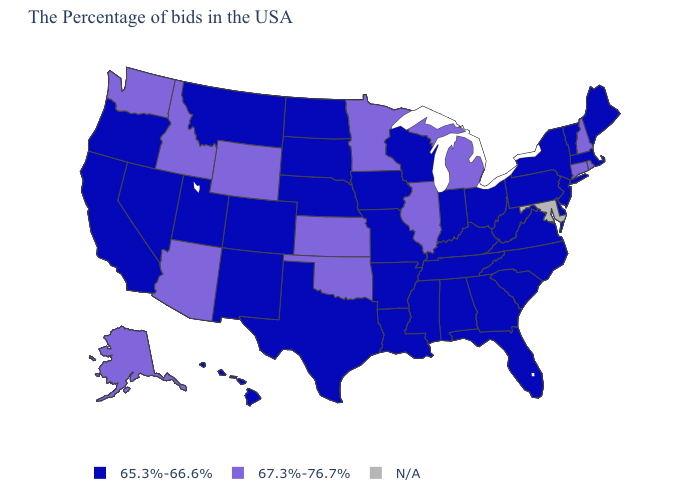Name the states that have a value in the range N/A?
Be succinct. Maryland. What is the value of Vermont?
Give a very brief answer. 65.3%-66.6%. Which states hav the highest value in the West?
Be succinct. Wyoming, Arizona, Idaho, Washington, Alaska. Does the map have missing data?
Give a very brief answer. Yes. Does the first symbol in the legend represent the smallest category?
Short answer required. Yes. Does the map have missing data?
Give a very brief answer. Yes. What is the highest value in the USA?
Write a very short answer. 67.3%-76.7%. What is the value of Mississippi?
Quick response, please. 65.3%-66.6%. Name the states that have a value in the range 67.3%-76.7%?
Short answer required. Rhode Island, New Hampshire, Connecticut, Michigan, Illinois, Minnesota, Kansas, Oklahoma, Wyoming, Arizona, Idaho, Washington, Alaska. What is the value of Washington?
Give a very brief answer. 67.3%-76.7%. Name the states that have a value in the range 65.3%-66.6%?
Concise answer only. Maine, Massachusetts, Vermont, New York, New Jersey, Delaware, Pennsylvania, Virginia, North Carolina, South Carolina, West Virginia, Ohio, Florida, Georgia, Kentucky, Indiana, Alabama, Tennessee, Wisconsin, Mississippi, Louisiana, Missouri, Arkansas, Iowa, Nebraska, Texas, South Dakota, North Dakota, Colorado, New Mexico, Utah, Montana, Nevada, California, Oregon, Hawaii. How many symbols are there in the legend?
Short answer required. 3. What is the lowest value in the MidWest?
Give a very brief answer. 65.3%-66.6%. 